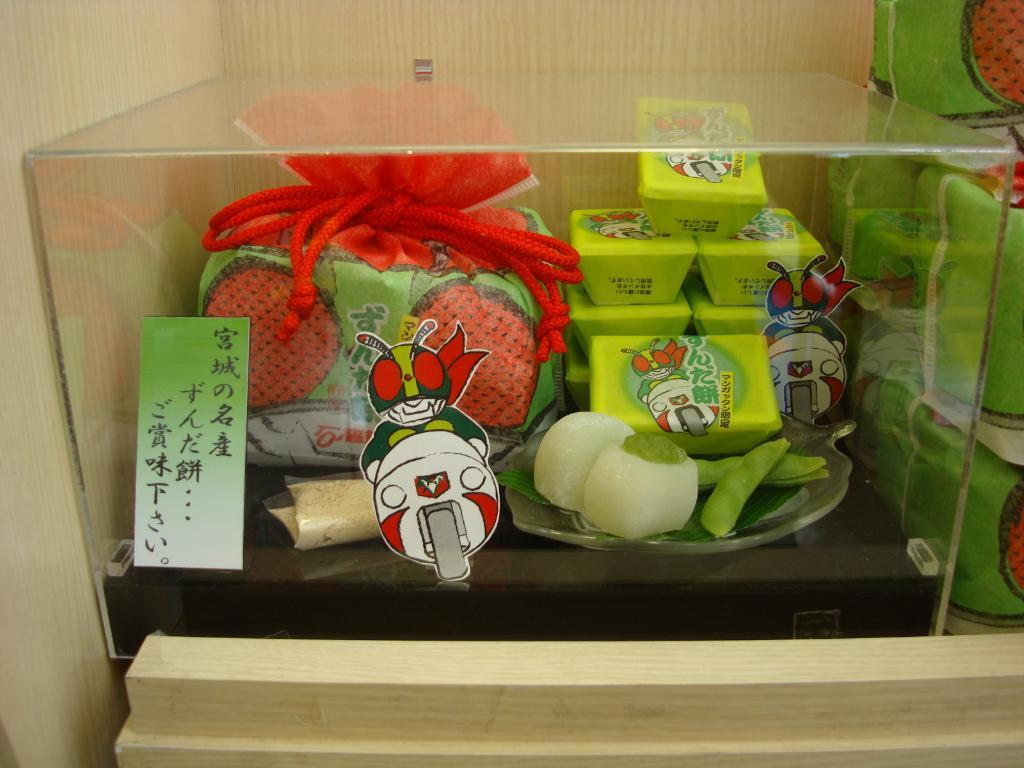What is contained within the glass box in the image? There are food items in a glass box in the image. Are there any additional features on the glass box? Yes, there are stickers on the stickers on the glass box. What else can be seen on the right side of the image? There are food packets or bags on the right side of the image. Can you see any quills being used to write on the food packets in the image? There are no quills or writing activity visible on the food packets in the image. 